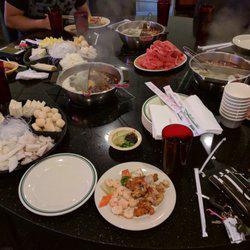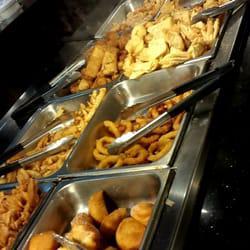The first image is the image on the left, the second image is the image on the right. For the images shown, is this caption "All the tongs are black and sliver." true? Answer yes or no. Yes. The first image is the image on the left, the second image is the image on the right. Considering the images on both sides, is "The right image shows tongs by rows of steel bins full of food, and the left image includes a white food plate surrounded by other dishware items on a dark table." valid? Answer yes or no. Yes. 